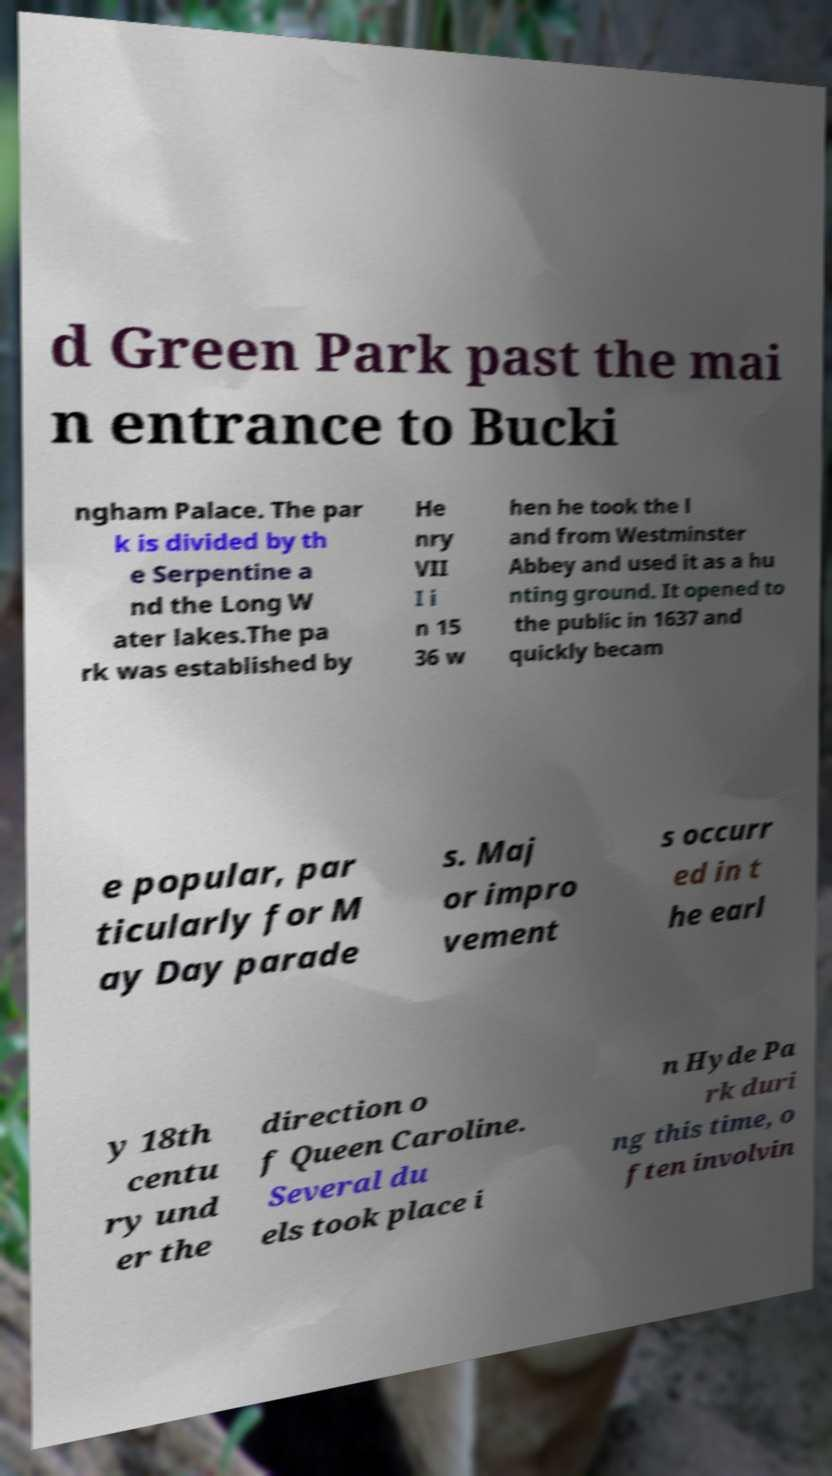Can you read and provide the text displayed in the image?This photo seems to have some interesting text. Can you extract and type it out for me? d Green Park past the mai n entrance to Bucki ngham Palace. The par k is divided by th e Serpentine a nd the Long W ater lakes.The pa rk was established by He nry VII I i n 15 36 w hen he took the l and from Westminster Abbey and used it as a hu nting ground. It opened to the public in 1637 and quickly becam e popular, par ticularly for M ay Day parade s. Maj or impro vement s occurr ed in t he earl y 18th centu ry und er the direction o f Queen Caroline. Several du els took place i n Hyde Pa rk duri ng this time, o ften involvin 